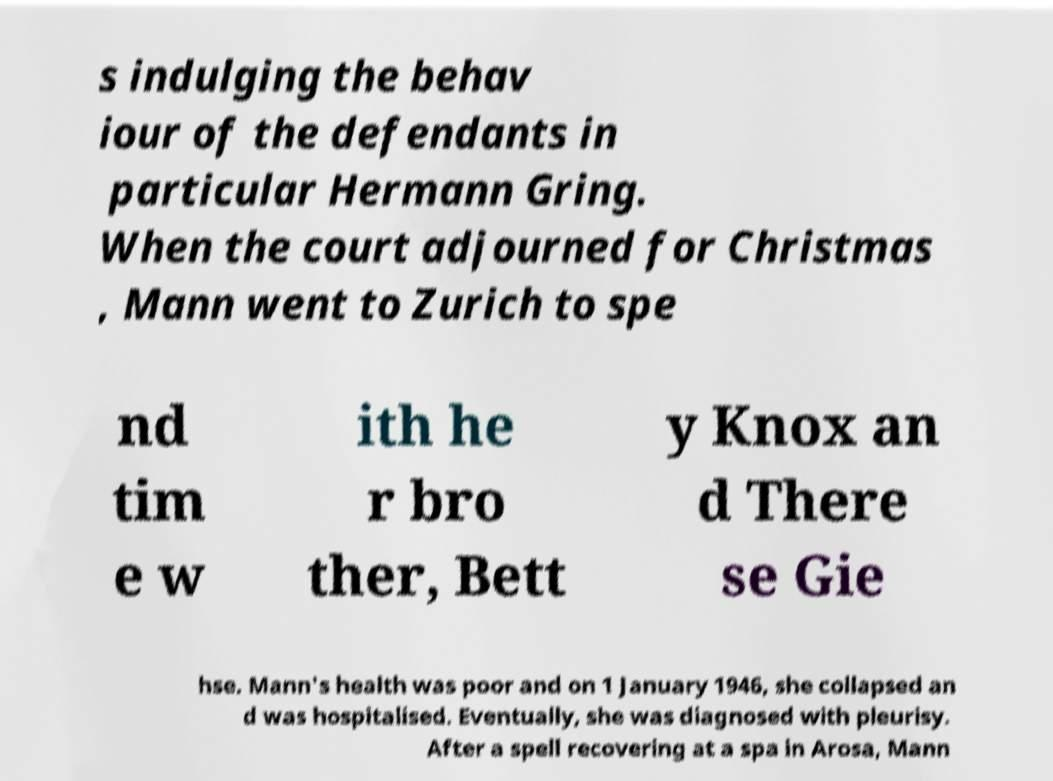Could you assist in decoding the text presented in this image and type it out clearly? s indulging the behav iour of the defendants in particular Hermann Gring. When the court adjourned for Christmas , Mann went to Zurich to spe nd tim e w ith he r bro ther, Bett y Knox an d There se Gie hse. Mann's health was poor and on 1 January 1946, she collapsed an d was hospitalised. Eventually, she was diagnosed with pleurisy. After a spell recovering at a spa in Arosa, Mann 